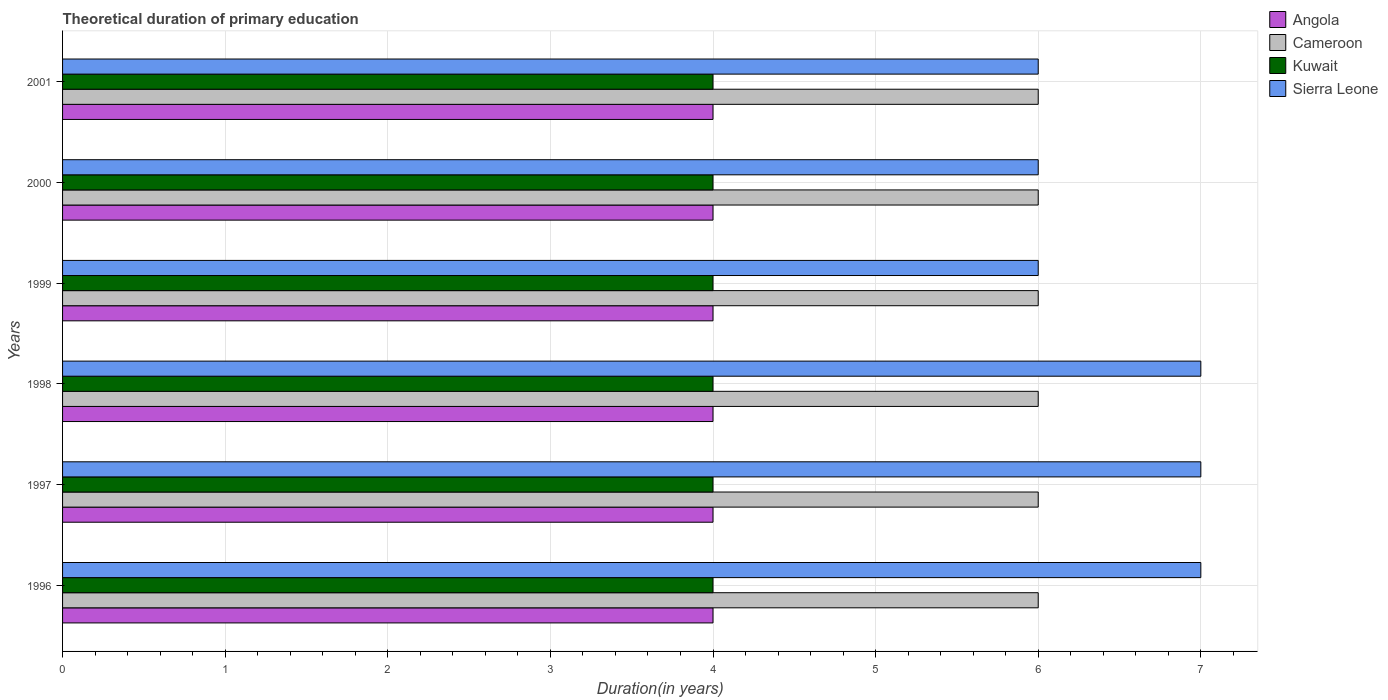How many bars are there on the 2nd tick from the top?
Keep it short and to the point. 4. In how many cases, is the number of bars for a given year not equal to the number of legend labels?
Your answer should be compact. 0. Across all years, what is the maximum total theoretical duration of primary education in Sierra Leone?
Provide a short and direct response. 7. Across all years, what is the minimum total theoretical duration of primary education in Kuwait?
Provide a succinct answer. 4. In which year was the total theoretical duration of primary education in Angola maximum?
Offer a very short reply. 1996. In which year was the total theoretical duration of primary education in Cameroon minimum?
Your response must be concise. 1996. What is the total total theoretical duration of primary education in Sierra Leone in the graph?
Make the answer very short. 39. What is the difference between the total theoretical duration of primary education in Angola in 1997 and the total theoretical duration of primary education in Cameroon in 2001?
Give a very brief answer. -2. In the year 2000, what is the difference between the total theoretical duration of primary education in Kuwait and total theoretical duration of primary education in Angola?
Your response must be concise. 0. Is the total theoretical duration of primary education in Sierra Leone in 1997 less than that in 2001?
Keep it short and to the point. No. Is the difference between the total theoretical duration of primary education in Kuwait in 1996 and 2000 greater than the difference between the total theoretical duration of primary education in Angola in 1996 and 2000?
Offer a terse response. No. What is the difference between the highest and the lowest total theoretical duration of primary education in Sierra Leone?
Your answer should be very brief. 1. In how many years, is the total theoretical duration of primary education in Angola greater than the average total theoretical duration of primary education in Angola taken over all years?
Offer a very short reply. 0. What does the 2nd bar from the top in 2001 represents?
Keep it short and to the point. Kuwait. What does the 1st bar from the bottom in 2001 represents?
Your response must be concise. Angola. Are all the bars in the graph horizontal?
Offer a terse response. Yes. How many years are there in the graph?
Provide a short and direct response. 6. What is the difference between two consecutive major ticks on the X-axis?
Offer a very short reply. 1. Does the graph contain any zero values?
Provide a short and direct response. No. Does the graph contain grids?
Keep it short and to the point. Yes. Where does the legend appear in the graph?
Your answer should be very brief. Top right. How many legend labels are there?
Offer a terse response. 4. What is the title of the graph?
Your response must be concise. Theoretical duration of primary education. What is the label or title of the X-axis?
Your answer should be compact. Duration(in years). What is the Duration(in years) of Cameroon in 1996?
Give a very brief answer. 6. What is the Duration(in years) of Kuwait in 1996?
Your answer should be very brief. 4. What is the Duration(in years) of Sierra Leone in 1996?
Your answer should be very brief. 7. What is the Duration(in years) of Sierra Leone in 1997?
Make the answer very short. 7. What is the Duration(in years) of Kuwait in 1998?
Make the answer very short. 4. What is the Duration(in years) in Sierra Leone in 1998?
Your answer should be compact. 7. What is the Duration(in years) of Cameroon in 1999?
Give a very brief answer. 6. What is the Duration(in years) of Sierra Leone in 1999?
Ensure brevity in your answer.  6. What is the Duration(in years) of Kuwait in 2000?
Your response must be concise. 4. What is the Duration(in years) in Angola in 2001?
Provide a short and direct response. 4. What is the Duration(in years) of Cameroon in 2001?
Keep it short and to the point. 6. Across all years, what is the maximum Duration(in years) in Kuwait?
Provide a succinct answer. 4. Across all years, what is the maximum Duration(in years) of Sierra Leone?
Provide a succinct answer. 7. Across all years, what is the minimum Duration(in years) in Angola?
Your answer should be compact. 4. Across all years, what is the minimum Duration(in years) of Cameroon?
Offer a terse response. 6. Across all years, what is the minimum Duration(in years) in Kuwait?
Make the answer very short. 4. What is the total Duration(in years) of Cameroon in the graph?
Your answer should be very brief. 36. What is the total Duration(in years) in Kuwait in the graph?
Keep it short and to the point. 24. What is the difference between the Duration(in years) of Angola in 1996 and that in 1997?
Offer a terse response. 0. What is the difference between the Duration(in years) in Cameroon in 1996 and that in 1997?
Offer a terse response. 0. What is the difference between the Duration(in years) of Cameroon in 1996 and that in 1998?
Provide a succinct answer. 0. What is the difference between the Duration(in years) in Kuwait in 1996 and that in 1998?
Your response must be concise. 0. What is the difference between the Duration(in years) in Cameroon in 1996 and that in 1999?
Offer a terse response. 0. What is the difference between the Duration(in years) in Angola in 1996 and that in 2000?
Make the answer very short. 0. What is the difference between the Duration(in years) of Kuwait in 1996 and that in 2000?
Make the answer very short. 0. What is the difference between the Duration(in years) of Sierra Leone in 1996 and that in 2000?
Ensure brevity in your answer.  1. What is the difference between the Duration(in years) of Cameroon in 1996 and that in 2001?
Make the answer very short. 0. What is the difference between the Duration(in years) in Kuwait in 1997 and that in 1998?
Your answer should be compact. 0. What is the difference between the Duration(in years) in Sierra Leone in 1997 and that in 1998?
Provide a succinct answer. 0. What is the difference between the Duration(in years) in Angola in 1997 and that in 1999?
Offer a terse response. 0. What is the difference between the Duration(in years) of Angola in 1997 and that in 2000?
Offer a very short reply. 0. What is the difference between the Duration(in years) of Cameroon in 1997 and that in 2000?
Make the answer very short. 0. What is the difference between the Duration(in years) of Sierra Leone in 1997 and that in 2000?
Ensure brevity in your answer.  1. What is the difference between the Duration(in years) of Kuwait in 1997 and that in 2001?
Provide a short and direct response. 0. What is the difference between the Duration(in years) of Sierra Leone in 1997 and that in 2001?
Ensure brevity in your answer.  1. What is the difference between the Duration(in years) of Kuwait in 1998 and that in 1999?
Give a very brief answer. 0. What is the difference between the Duration(in years) in Sierra Leone in 1998 and that in 1999?
Your response must be concise. 1. What is the difference between the Duration(in years) in Angola in 1998 and that in 2000?
Offer a terse response. 0. What is the difference between the Duration(in years) in Cameroon in 1998 and that in 2000?
Provide a short and direct response. 0. What is the difference between the Duration(in years) of Angola in 1998 and that in 2001?
Give a very brief answer. 0. What is the difference between the Duration(in years) of Kuwait in 1998 and that in 2001?
Give a very brief answer. 0. What is the difference between the Duration(in years) of Kuwait in 1999 and that in 2000?
Your answer should be very brief. 0. What is the difference between the Duration(in years) of Kuwait in 1999 and that in 2001?
Offer a terse response. 0. What is the difference between the Duration(in years) in Sierra Leone in 1999 and that in 2001?
Your answer should be compact. 0. What is the difference between the Duration(in years) in Sierra Leone in 2000 and that in 2001?
Offer a very short reply. 0. What is the difference between the Duration(in years) of Angola in 1996 and the Duration(in years) of Cameroon in 1997?
Provide a succinct answer. -2. What is the difference between the Duration(in years) in Angola in 1996 and the Duration(in years) in Sierra Leone in 1997?
Make the answer very short. -3. What is the difference between the Duration(in years) of Cameroon in 1996 and the Duration(in years) of Sierra Leone in 1997?
Offer a very short reply. -1. What is the difference between the Duration(in years) in Angola in 1996 and the Duration(in years) in Cameroon in 1998?
Your response must be concise. -2. What is the difference between the Duration(in years) of Angola in 1996 and the Duration(in years) of Sierra Leone in 1999?
Give a very brief answer. -2. What is the difference between the Duration(in years) in Cameroon in 1996 and the Duration(in years) in Kuwait in 1999?
Your answer should be compact. 2. What is the difference between the Duration(in years) in Cameroon in 1996 and the Duration(in years) in Sierra Leone in 1999?
Offer a terse response. 0. What is the difference between the Duration(in years) in Kuwait in 1996 and the Duration(in years) in Sierra Leone in 1999?
Provide a succinct answer. -2. What is the difference between the Duration(in years) of Angola in 1996 and the Duration(in years) of Cameroon in 2000?
Keep it short and to the point. -2. What is the difference between the Duration(in years) in Angola in 1996 and the Duration(in years) in Sierra Leone in 2000?
Provide a succinct answer. -2. What is the difference between the Duration(in years) in Kuwait in 1996 and the Duration(in years) in Sierra Leone in 2000?
Provide a short and direct response. -2. What is the difference between the Duration(in years) in Cameroon in 1996 and the Duration(in years) in Kuwait in 2001?
Provide a short and direct response. 2. What is the difference between the Duration(in years) of Cameroon in 1996 and the Duration(in years) of Sierra Leone in 2001?
Offer a very short reply. 0. What is the difference between the Duration(in years) of Angola in 1997 and the Duration(in years) of Kuwait in 1998?
Provide a short and direct response. 0. What is the difference between the Duration(in years) of Cameroon in 1997 and the Duration(in years) of Kuwait in 1998?
Offer a terse response. 2. What is the difference between the Duration(in years) of Angola in 1997 and the Duration(in years) of Kuwait in 1999?
Keep it short and to the point. 0. What is the difference between the Duration(in years) of Cameroon in 1997 and the Duration(in years) of Sierra Leone in 1999?
Keep it short and to the point. 0. What is the difference between the Duration(in years) in Kuwait in 1997 and the Duration(in years) in Sierra Leone in 1999?
Your answer should be compact. -2. What is the difference between the Duration(in years) in Angola in 1997 and the Duration(in years) in Cameroon in 2000?
Make the answer very short. -2. What is the difference between the Duration(in years) of Angola in 1997 and the Duration(in years) of Kuwait in 2000?
Your response must be concise. 0. What is the difference between the Duration(in years) of Cameroon in 1997 and the Duration(in years) of Kuwait in 2000?
Offer a terse response. 2. What is the difference between the Duration(in years) in Cameroon in 1997 and the Duration(in years) in Sierra Leone in 2000?
Ensure brevity in your answer.  0. What is the difference between the Duration(in years) in Angola in 1997 and the Duration(in years) in Cameroon in 2001?
Your answer should be very brief. -2. What is the difference between the Duration(in years) in Angola in 1997 and the Duration(in years) in Kuwait in 2001?
Your answer should be very brief. 0. What is the difference between the Duration(in years) of Cameroon in 1997 and the Duration(in years) of Sierra Leone in 2001?
Your answer should be compact. 0. What is the difference between the Duration(in years) in Kuwait in 1997 and the Duration(in years) in Sierra Leone in 2001?
Your answer should be very brief. -2. What is the difference between the Duration(in years) of Angola in 1998 and the Duration(in years) of Sierra Leone in 1999?
Ensure brevity in your answer.  -2. What is the difference between the Duration(in years) in Angola in 1998 and the Duration(in years) in Kuwait in 2000?
Offer a very short reply. 0. What is the difference between the Duration(in years) in Cameroon in 1998 and the Duration(in years) in Sierra Leone in 2000?
Your answer should be compact. 0. What is the difference between the Duration(in years) in Kuwait in 1998 and the Duration(in years) in Sierra Leone in 2000?
Your answer should be compact. -2. What is the difference between the Duration(in years) in Angola in 1998 and the Duration(in years) in Kuwait in 2001?
Provide a succinct answer. 0. What is the difference between the Duration(in years) in Cameroon in 1998 and the Duration(in years) in Kuwait in 2001?
Your answer should be very brief. 2. What is the difference between the Duration(in years) in Cameroon in 1998 and the Duration(in years) in Sierra Leone in 2001?
Your answer should be compact. 0. What is the difference between the Duration(in years) in Kuwait in 1998 and the Duration(in years) in Sierra Leone in 2001?
Give a very brief answer. -2. What is the difference between the Duration(in years) of Angola in 1999 and the Duration(in years) of Kuwait in 2000?
Offer a terse response. 0. What is the difference between the Duration(in years) in Angola in 1999 and the Duration(in years) in Sierra Leone in 2000?
Ensure brevity in your answer.  -2. What is the difference between the Duration(in years) in Cameroon in 1999 and the Duration(in years) in Kuwait in 2000?
Give a very brief answer. 2. What is the difference between the Duration(in years) of Cameroon in 1999 and the Duration(in years) of Kuwait in 2001?
Ensure brevity in your answer.  2. What is the difference between the Duration(in years) of Cameroon in 1999 and the Duration(in years) of Sierra Leone in 2001?
Offer a terse response. 0. What is the difference between the Duration(in years) of Angola in 2000 and the Duration(in years) of Cameroon in 2001?
Your answer should be compact. -2. What is the difference between the Duration(in years) in Angola in 2000 and the Duration(in years) in Kuwait in 2001?
Offer a very short reply. 0. What is the difference between the Duration(in years) in Cameroon in 2000 and the Duration(in years) in Kuwait in 2001?
Your response must be concise. 2. What is the average Duration(in years) in Angola per year?
Give a very brief answer. 4. What is the average Duration(in years) in Sierra Leone per year?
Offer a terse response. 6.5. In the year 1996, what is the difference between the Duration(in years) of Angola and Duration(in years) of Kuwait?
Provide a succinct answer. 0. In the year 1996, what is the difference between the Duration(in years) of Cameroon and Duration(in years) of Sierra Leone?
Make the answer very short. -1. In the year 1996, what is the difference between the Duration(in years) of Kuwait and Duration(in years) of Sierra Leone?
Offer a terse response. -3. In the year 1997, what is the difference between the Duration(in years) of Angola and Duration(in years) of Cameroon?
Keep it short and to the point. -2. In the year 1997, what is the difference between the Duration(in years) in Cameroon and Duration(in years) in Sierra Leone?
Offer a terse response. -1. In the year 1998, what is the difference between the Duration(in years) in Angola and Duration(in years) in Cameroon?
Give a very brief answer. -2. In the year 1998, what is the difference between the Duration(in years) of Kuwait and Duration(in years) of Sierra Leone?
Keep it short and to the point. -3. In the year 1999, what is the difference between the Duration(in years) of Angola and Duration(in years) of Cameroon?
Provide a succinct answer. -2. In the year 1999, what is the difference between the Duration(in years) of Angola and Duration(in years) of Sierra Leone?
Ensure brevity in your answer.  -2. In the year 1999, what is the difference between the Duration(in years) of Kuwait and Duration(in years) of Sierra Leone?
Provide a succinct answer. -2. In the year 2000, what is the difference between the Duration(in years) in Angola and Duration(in years) in Cameroon?
Keep it short and to the point. -2. In the year 2000, what is the difference between the Duration(in years) in Angola and Duration(in years) in Sierra Leone?
Offer a terse response. -2. In the year 2000, what is the difference between the Duration(in years) in Kuwait and Duration(in years) in Sierra Leone?
Provide a succinct answer. -2. In the year 2001, what is the difference between the Duration(in years) of Angola and Duration(in years) of Cameroon?
Provide a succinct answer. -2. In the year 2001, what is the difference between the Duration(in years) of Angola and Duration(in years) of Kuwait?
Your answer should be very brief. 0. In the year 2001, what is the difference between the Duration(in years) in Cameroon and Duration(in years) in Kuwait?
Your answer should be very brief. 2. In the year 2001, what is the difference between the Duration(in years) of Cameroon and Duration(in years) of Sierra Leone?
Offer a very short reply. 0. In the year 2001, what is the difference between the Duration(in years) in Kuwait and Duration(in years) in Sierra Leone?
Offer a very short reply. -2. What is the ratio of the Duration(in years) in Angola in 1996 to that in 1997?
Your response must be concise. 1. What is the ratio of the Duration(in years) of Cameroon in 1996 to that in 1997?
Offer a terse response. 1. What is the ratio of the Duration(in years) of Cameroon in 1996 to that in 1998?
Your answer should be very brief. 1. What is the ratio of the Duration(in years) in Kuwait in 1996 to that in 1998?
Make the answer very short. 1. What is the ratio of the Duration(in years) of Cameroon in 1996 to that in 1999?
Offer a terse response. 1. What is the ratio of the Duration(in years) in Angola in 1996 to that in 2000?
Offer a very short reply. 1. What is the ratio of the Duration(in years) of Angola in 1996 to that in 2001?
Provide a succinct answer. 1. What is the ratio of the Duration(in years) of Cameroon in 1996 to that in 2001?
Give a very brief answer. 1. What is the ratio of the Duration(in years) in Sierra Leone in 1996 to that in 2001?
Provide a short and direct response. 1.17. What is the ratio of the Duration(in years) of Angola in 1997 to that in 1998?
Your answer should be very brief. 1. What is the ratio of the Duration(in years) of Angola in 1997 to that in 1999?
Provide a short and direct response. 1. What is the ratio of the Duration(in years) in Kuwait in 1997 to that in 1999?
Give a very brief answer. 1. What is the ratio of the Duration(in years) in Sierra Leone in 1997 to that in 1999?
Your answer should be very brief. 1.17. What is the ratio of the Duration(in years) in Cameroon in 1997 to that in 2000?
Your answer should be very brief. 1. What is the ratio of the Duration(in years) of Angola in 1997 to that in 2001?
Offer a terse response. 1. What is the ratio of the Duration(in years) of Sierra Leone in 1997 to that in 2001?
Your answer should be compact. 1.17. What is the ratio of the Duration(in years) in Kuwait in 1998 to that in 1999?
Provide a short and direct response. 1. What is the ratio of the Duration(in years) in Sierra Leone in 1998 to that in 2000?
Make the answer very short. 1.17. What is the ratio of the Duration(in years) of Angola in 1998 to that in 2001?
Your answer should be compact. 1. What is the ratio of the Duration(in years) of Kuwait in 1998 to that in 2001?
Offer a very short reply. 1. What is the ratio of the Duration(in years) in Cameroon in 1999 to that in 2001?
Your answer should be very brief. 1. What is the ratio of the Duration(in years) of Sierra Leone in 1999 to that in 2001?
Your answer should be very brief. 1. What is the ratio of the Duration(in years) of Angola in 2000 to that in 2001?
Your answer should be compact. 1. What is the ratio of the Duration(in years) in Cameroon in 2000 to that in 2001?
Keep it short and to the point. 1. What is the ratio of the Duration(in years) in Sierra Leone in 2000 to that in 2001?
Your answer should be compact. 1. What is the difference between the highest and the second highest Duration(in years) in Angola?
Offer a very short reply. 0. What is the difference between the highest and the second highest Duration(in years) of Cameroon?
Your response must be concise. 0. What is the difference between the highest and the second highest Duration(in years) in Sierra Leone?
Your response must be concise. 0. What is the difference between the highest and the lowest Duration(in years) in Angola?
Give a very brief answer. 0. What is the difference between the highest and the lowest Duration(in years) in Sierra Leone?
Give a very brief answer. 1. 